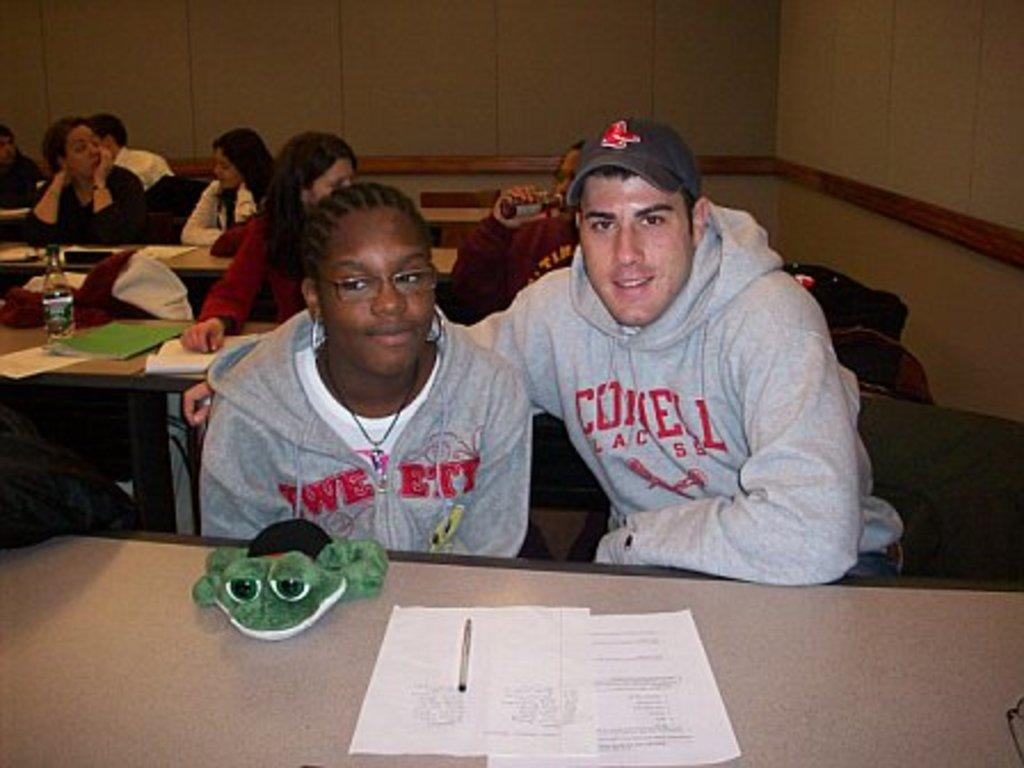What are the persons in the image doing? The persons in the image are sitting on chairs. What is one person holding in the image? One person is holding a bottle. What items can be seen on the tables in the image? Papers, bottles, toys, pens, and books are on the tables in the image. What is visible in the background of the image? There is a wall in the background. How many turkeys are visible in the image? There are no turkeys present in the image. What type of grip does the person holding the bottle have on it? The image does not provide enough detail to determine the type of grip the person has on the bottle. 